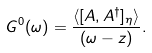Convert formula to latex. <formula><loc_0><loc_0><loc_500><loc_500>G ^ { 0 } ( \omega ) = \frac { \langle [ A , A ^ { \dagger } ] _ { \eta } \rangle } { ( \omega - z ) } .</formula> 